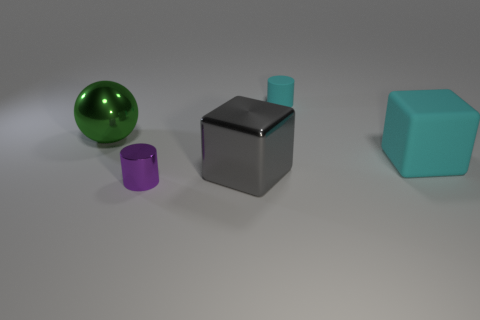Add 5 tiny metal objects. How many objects exist? 10 Subtract all spheres. How many objects are left? 4 Add 2 tiny matte objects. How many tiny matte objects exist? 3 Subtract 0 yellow cylinders. How many objects are left? 5 Subtract all blue balls. Subtract all large gray shiny blocks. How many objects are left? 4 Add 5 cyan matte cylinders. How many cyan matte cylinders are left? 6 